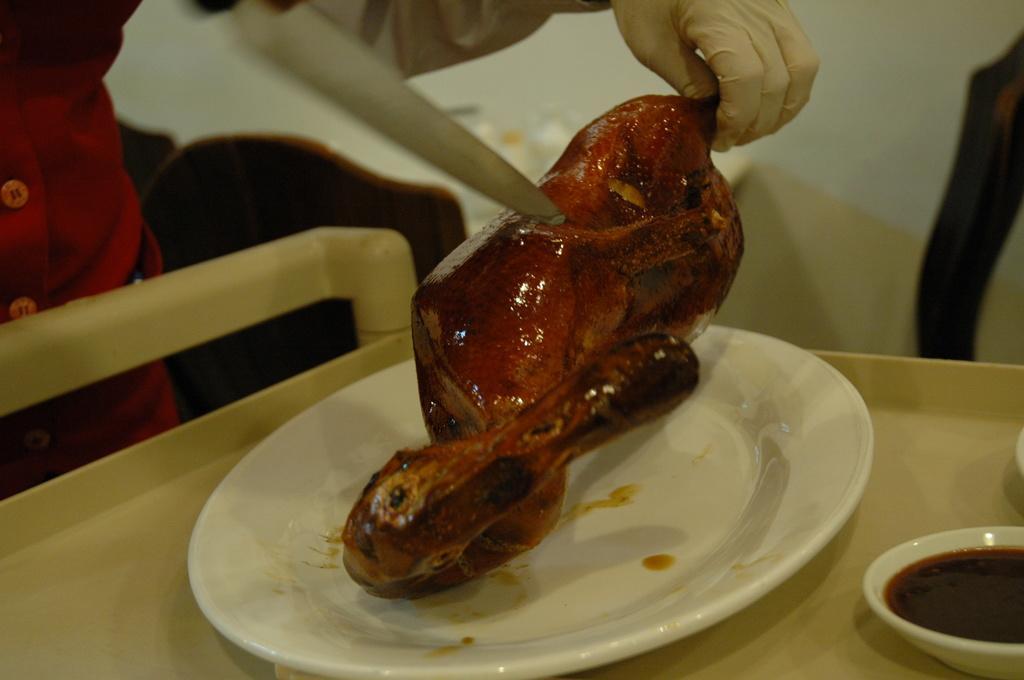In one or two sentences, can you explain what this image depicts? In this picture we can see a person wearing a glove. This is a knife. Here we can see a meat and a white plate. Here we can see liquid in a bowl. 